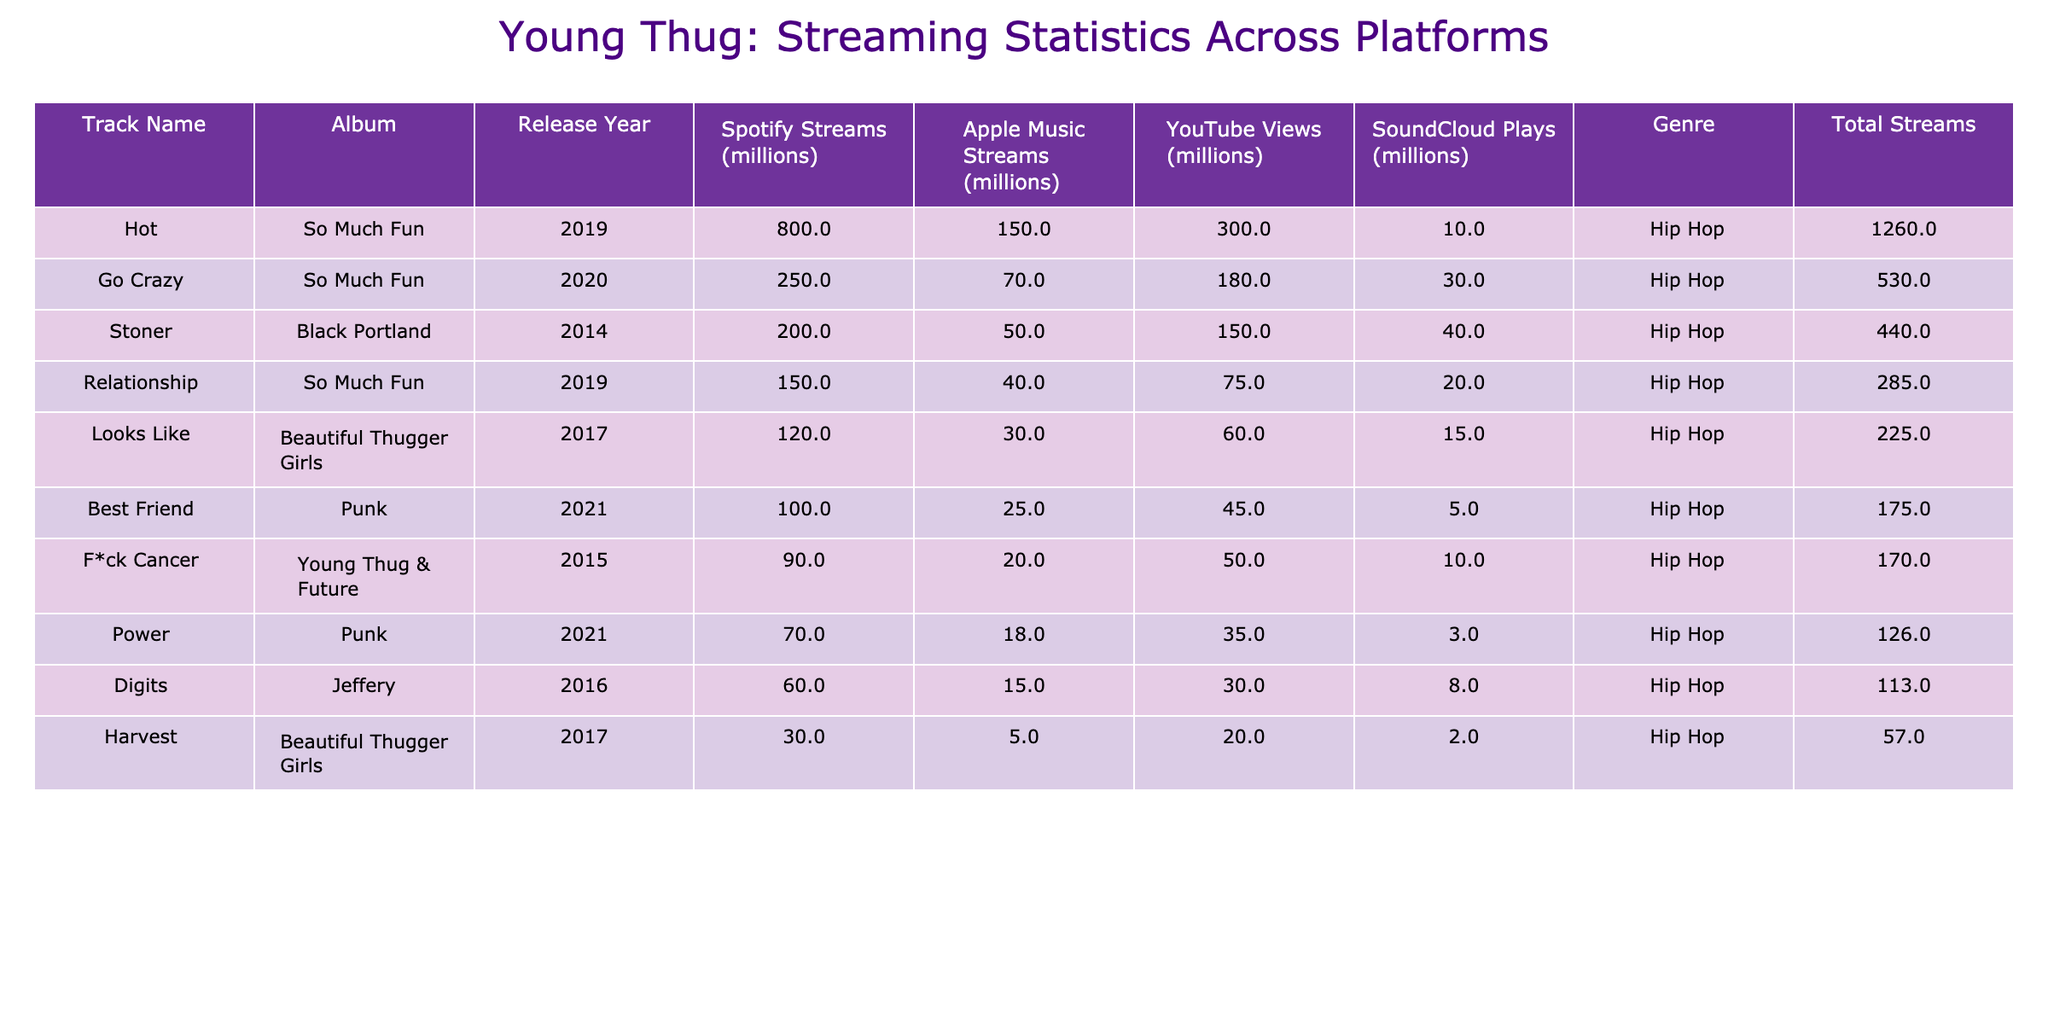What's the track with the highest Spotify streams? The table shows that "Hot" has the highest Spotify streams with 800 million.
Answer: "Hot" Which track has the least SoundCloud plays? Upon reviewing the table, "Power" has the least SoundCloud plays, recorded at 3 million.
Answer: "Power" What is the total combined streaming count for "Stoner"? Combining the streams from Spotify (200 million), Apple Music (50 million), YouTube (150 million), and SoundCloud (40 million), the total for "Stoner" is 440 million.
Answer: 440 million Which track has more YouTube views: "Go Crazy" or "Stoner"? Comparing the YouTube views, "Go Crazy" has 180 million views, while "Stoner" has 150 million views; therefore, "Go Crazy" has more views.
Answer: "Go Crazy" Is "Looks Like" more popular on Apple Music than "Best Friend"? "Looks Like" has 30 million Apple Music streams, while "Best Friend" has 25 million; thus, "Looks Like" is more popular.
Answer: Yes What is the average number of Spotify streams for tracks released in 2019? The tracks from 2019 are "Relationship" (150 million) and "Hot" (800 million). Their total is 950 million, and with 2 tracks, the average becomes 950/2 = 475 million.
Answer: 475 million Which album has the highest total streaming count across its tracks? Calculating the total for each album: "So Much Fun" (150 + 800 + 250 = 1200 million), "Punk" (100 + 70 = 170 million), "Beautiful Thugger Girls" (120 + 30 = 150 million), and "Black Portland" (200 million). The highest is "So Much Fun" at 1200 million.
Answer: "So Much Fun" Is "F*ck Cancer" the only track released in 2015? The table indicates that "F*ck Cancer" is indeed the only track listed from 2015.
Answer: Yes What is the total streaming count for "Go Crazy" across all platforms? "Go Crazy" has streams of 250 million (Spotify), 70 million (Apple Music), 180 million (YouTube), and 30 million (SoundCloud), combining for a total of 530 million.
Answer: 530 million Which track has the highest view-count on YouTube? The view-count on YouTube shows that "Hot" has the highest views at 300 million.
Answer: "Hot" Compare the total streams for "Harvest" and "Digits". Which one is higher? "Harvest" sums up to 57 million (30+5+20+2) and "Digits" totals to 113 million (60+15+30+8); thus, "Digits" has a higher total.
Answer: "Digits" 